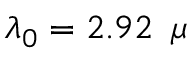<formula> <loc_0><loc_0><loc_500><loc_500>\lambda _ { 0 } = 2 . 9 2 \, \mu</formula> 